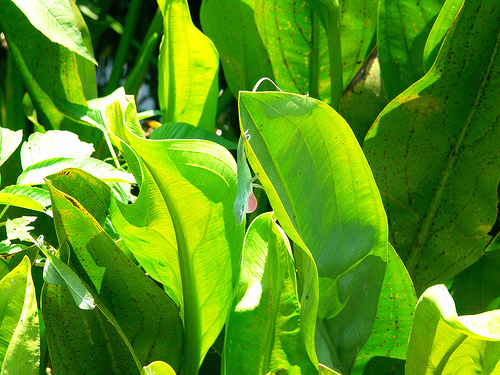<image>
Is the lizard under the leaf? Yes. The lizard is positioned underneath the leaf, with the leaf above it in the vertical space. 